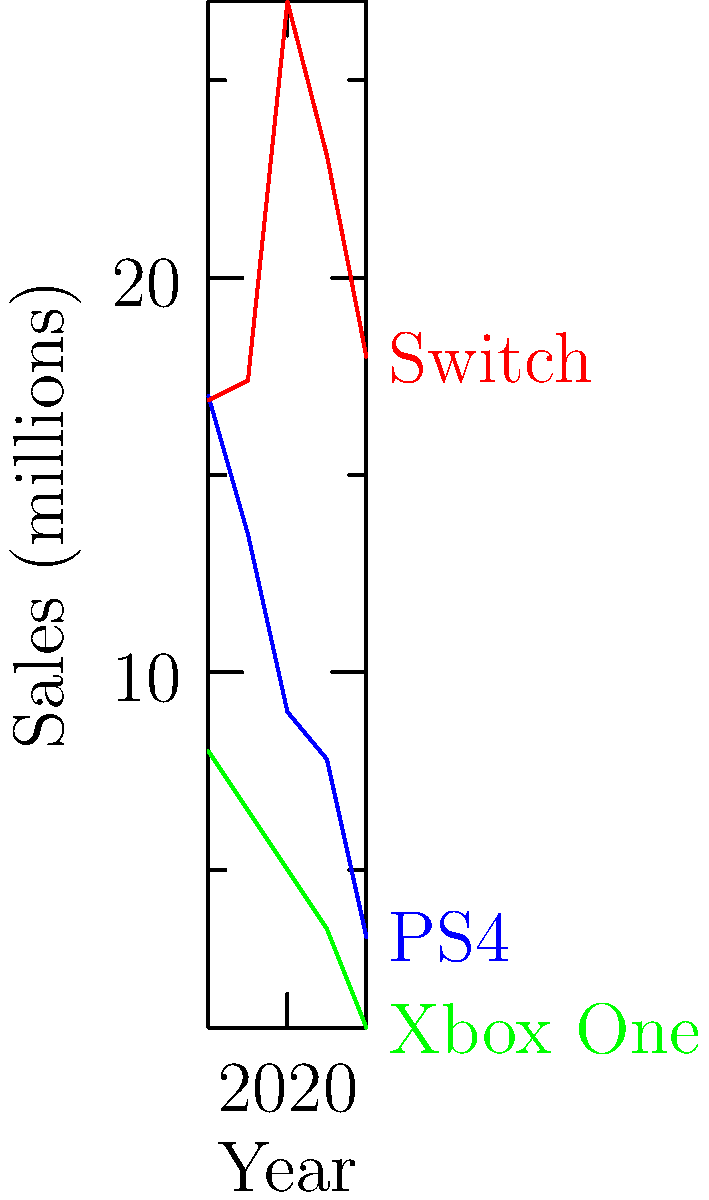In the graph showing console sales trends from 2018 to 2022, what is the approximate angle (in degrees) between the Switch and PS4 sales lines measured at the 2020 data point? To find the angle between the Switch and PS4 sales lines at the 2020 data point, we'll follow these steps:

1. Identify the relevant data points:
   - Switch 2020: (2020, 27)
   - PS4 2020: (2020, 9)
   - We'll also need the adjacent points for each console to determine the line slopes.

2. Calculate the slopes of both lines:
   - For Switch: $m_1 = \frac{27 - 17.4}{2020 - 2019} = 9.6$
   - For PS4: $m_2 = \frac{9 - 13.5}{2020 - 2019} = -4.5$

3. Use the formula for the angle between two lines:
   $\tan \theta = |\frac{m_1 - m_2}{1 + m_1m_2}|$

4. Plug in the values:
   $\tan \theta = |\frac{9.6 - (-4.5)}{1 + 9.6 \times (-4.5)}| = |\frac{14.1}{-42.2}| = 0.3341$

5. Take the inverse tangent (arctangent) to find the angle:
   $\theta = \arctan(0.3341) \approx 18.5°$

Therefore, the approximate angle between the Switch and PS4 sales lines at the 2020 data point is 18.5°.
Answer: 18.5° 